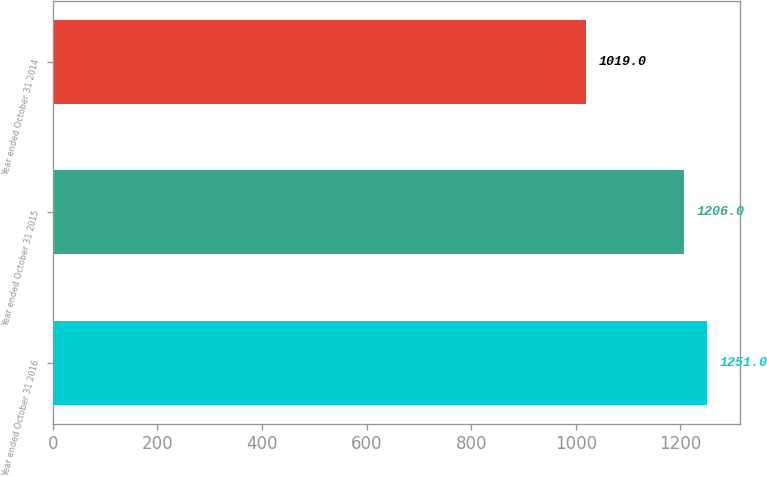Convert chart to OTSL. <chart><loc_0><loc_0><loc_500><loc_500><bar_chart><fcel>Year ended October 31 2016<fcel>Year ended October 31 2015<fcel>Year ended October 31 2014<nl><fcel>1251<fcel>1206<fcel>1019<nl></chart> 